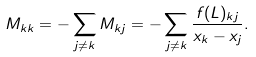<formula> <loc_0><loc_0><loc_500><loc_500>M _ { k k } = - \sum _ { j \neq k } M _ { k j } = - \sum _ { j \neq k } \frac { f ( L ) _ { k j } } { x _ { k } - x _ { j } } .</formula> 